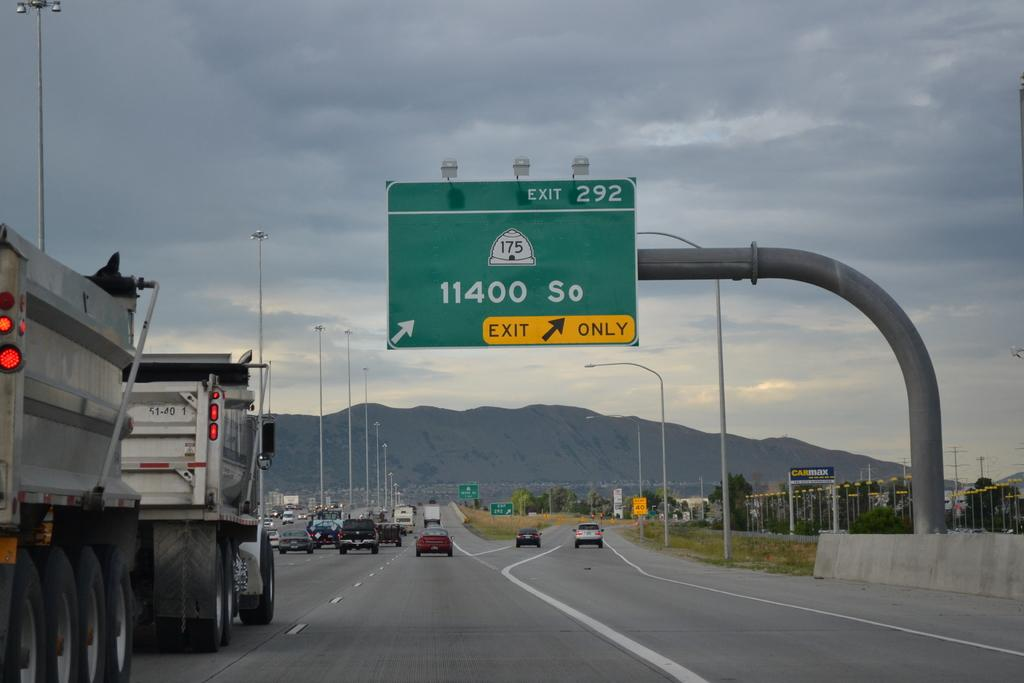<image>
Relay a brief, clear account of the picture shown. The sign indicates exit 292 will take you to 11400 So. 